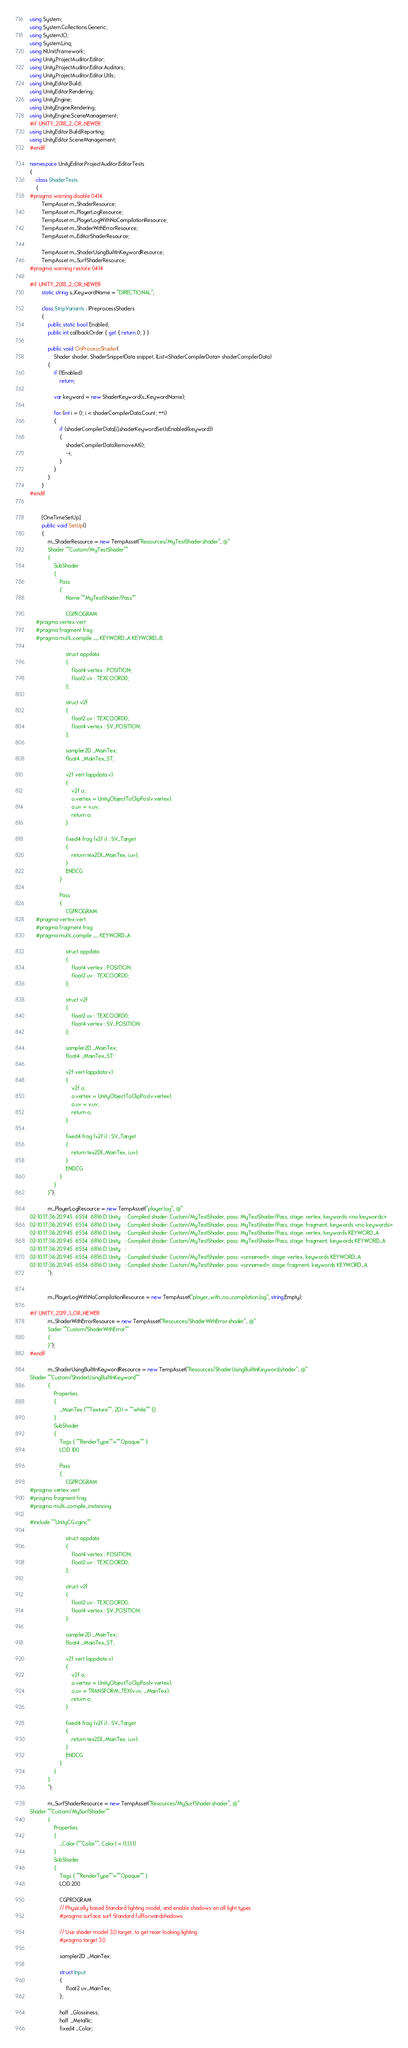Convert code to text. <code><loc_0><loc_0><loc_500><loc_500><_C#_>using System;
using System.Collections.Generic;
using System.IO;
using System.Linq;
using NUnit.Framework;
using Unity.ProjectAuditor.Editor;
using Unity.ProjectAuditor.Editor.Auditors;
using Unity.ProjectAuditor.Editor.Utils;
using UnityEditor.Build;
using UnityEditor.Rendering;
using UnityEngine;
using UnityEngine.Rendering;
using UnityEngine.SceneManagement;
#if UNITY_2018_2_OR_NEWER
using UnityEditor.Build.Reporting;
using UnityEditor.SceneManagement;
#endif

namespace UnityEditor.ProjectAuditor.EditorTests
{
    class ShaderTests
    {
#pragma warning disable 0414
        TempAsset m_ShaderResource;
        TempAsset m_PlayerLogResource;
        TempAsset m_PlayerLogWithNoCompilationResource;
        TempAsset m_ShaderWithErrorResource;
        TempAsset m_EditorShaderResource;

        TempAsset m_ShaderUsingBuiltInKeywordResource;
        TempAsset m_SurfShaderResource;
#pragma warning restore 0414

#if UNITY_2018_2_OR_NEWER
        static string s_KeywordName = "DIRECTIONAL";

        class StripVariants : IPreprocessShaders
        {
            public static bool Enabled;
            public int callbackOrder { get { return 0; } }

            public void OnProcessShader(
                Shader shader, ShaderSnippetData snippet, IList<ShaderCompilerData> shaderCompilerData)
            {
                if (!Enabled)
                    return;

                var keyword = new ShaderKeyword(s_KeywordName);

                for (int i = 0; i < shaderCompilerData.Count; ++i)
                {
                    if (shaderCompilerData[i].shaderKeywordSet.IsEnabled(keyword))
                    {
                        shaderCompilerData.RemoveAt(i);
                        --i;
                    }
                }
            }
        }
#endif


        [OneTimeSetUp]
        public void SetUp()
        {
            m_ShaderResource = new TempAsset("Resources/MyTestShader.shader", @"
            Shader ""Custom/MyTestShader""
            {
                SubShader
                {
                    Pass
                    {
                        Name ""MyTestShader/Pass""

                        CGPROGRAM
    #pragma vertex vert
    #pragma fragment frag
    #pragma multi_compile __ KEYWORD_A KEYWORD_B

                        struct appdata
                        {
                            float4 vertex : POSITION;
                            float2 uv : TEXCOORD0;
                        };

                        struct v2f
                        {
                            float2 uv : TEXCOORD0;
                            float4 vertex : SV_POSITION;
                        };

                        sampler2D _MainTex;
                        float4 _MainTex_ST;

                        v2f vert (appdata v)
                        {
                            v2f o;
                            o.vertex = UnityObjectToClipPos(v.vertex);
                            o.uv = v.uv;
                            return o;
                        }

                        fixed4 frag (v2f i) : SV_Target
                        {
                            return tex2D(_MainTex, i.uv);
                        }
                        ENDCG
                    }

                    Pass
                    {
                        CGPROGRAM
    #pragma vertex vert
    #pragma fragment frag
    #pragma multi_compile __ KEYWORD_A

                        struct appdata
                        {
                            float4 vertex : POSITION;
                            float2 uv : TEXCOORD0;
                        };

                        struct v2f
                        {
                            float2 uv : TEXCOORD0;
                            float4 vertex : SV_POSITION;
                        };

                        sampler2D _MainTex;
                        float4 _MainTex_ST;

                        v2f vert (appdata v)
                        {
                            v2f o;
                            o.vertex = UnityObjectToClipPos(v.vertex);
                            o.uv = v.uv;
                            return o;
                        }

                        fixed4 frag (v2f i) : SV_Target
                        {
                            return tex2D(_MainTex, i.uv);
                        }
                        ENDCG
                    }
                }
            }");

            m_PlayerLogResource = new TempAsset("player.log", @"
02-10 17:36:20.945  6554  6816 D Unity   : Compiled shader: Custom/MyTestShader, pass: MyTestShader/Pass, stage: vertex, keywords <no keywords>
02-10 17:36:20.945  6554  6816 D Unity   : Compiled shader: Custom/MyTestShader, pass: MyTestShader/Pass, stage: fragment, keywords <no keywords>
02-10 17:36:20.945  6554  6816 D Unity   : Compiled shader: Custom/MyTestShader, pass: MyTestShader/Pass, stage: vertex, keywords KEYWORD_A
02-10 17:36:20.945  6554  6816 D Unity   : Compiled shader: Custom/MyTestShader, pass: MyTestShader/Pass, stage: fragment, keywords KEYWORD_A
02-10 17:36:20.945  6554  6816 D Unity   :
02-10 17:36:20.945  6554  6816 D Unity   : Compiled shader: Custom/MyTestShader, pass: <unnamed>, stage: vertex, keywords KEYWORD_A
02-10 17:36:20.945  6554  6816 D Unity   : Compiled shader: Custom/MyTestShader, pass: <unnamed>, stage: fragment, keywords KEYWORD_A
            ");


            m_PlayerLogWithNoCompilationResource = new TempAsset("player_with_no_compilation.log", string.Empty);

#if UNITY_2019_1_OR_NEWER
            m_ShaderWithErrorResource = new TempAsset("Resources/ShaderWithError.shader", @"
            Sader ""Custom/ShaderWithError""
            {
            }");
#endif

            m_ShaderUsingBuiltInKeywordResource = new TempAsset("Resources/ShaderUsingBuiltInKeyword.shader", @"
Shader ""Custom/ShaderUsingBuiltInKeyword""
            {
                Properties
                {
                    _MainTex (""Texture"", 2D) = ""white"" {}
                }
                SubShader
                {
                    Tags { ""RenderType""=""Opaque"" }
                    LOD 100

                    Pass
                    {
                        CGPROGRAM
#pragma vertex vert
#pragma fragment frag
#pragma multi_compile_instancing

#include ""UnityCG.cginc""

                        struct appdata
                        {
                            float4 vertex : POSITION;
                            float2 uv : TEXCOORD0;
                        };

                        struct v2f
                        {
                            float2 uv : TEXCOORD0;
                            float4 vertex : SV_POSITION;
                        };

                        sampler2D _MainTex;
                        float4 _MainTex_ST;

                        v2f vert (appdata v)
                        {
                            v2f o;
                            o.vertex = UnityObjectToClipPos(v.vertex);
                            o.uv = TRANSFORM_TEX(v.uv, _MainTex);
                            return o;
                        }

                        fixed4 frag (v2f i) : SV_Target
                        {
                            return tex2D(_MainTex, i.uv);
                        }
                        ENDCG
                    }
                }
            }
            ");

            m_SurfShaderResource = new TempAsset("Resources/MySurfShader.shader", @"
Shader ""Custom/MySurfShader""
            {
                Properties
                {
                    _Color (""Color"", Color) = (1,1,1,1)
                }
                SubShader
                {
                    Tags { ""RenderType""=""Opaque"" }
                    LOD 200

                    CGPROGRAM
                    // Physically based Standard lighting model, and enable shadows on all light types
                    #pragma surface surf Standard fullforwardshadows

                    // Use shader model 3.0 target, to get nicer looking lighting
                    #pragma target 3.0

                    sampler2D _MainTex;

                    struct Input
                    {
                        float2 uv_MainTex;
                    };

                    half _Glossiness;
                    half _Metallic;
                    fixed4 _Color;
</code> 